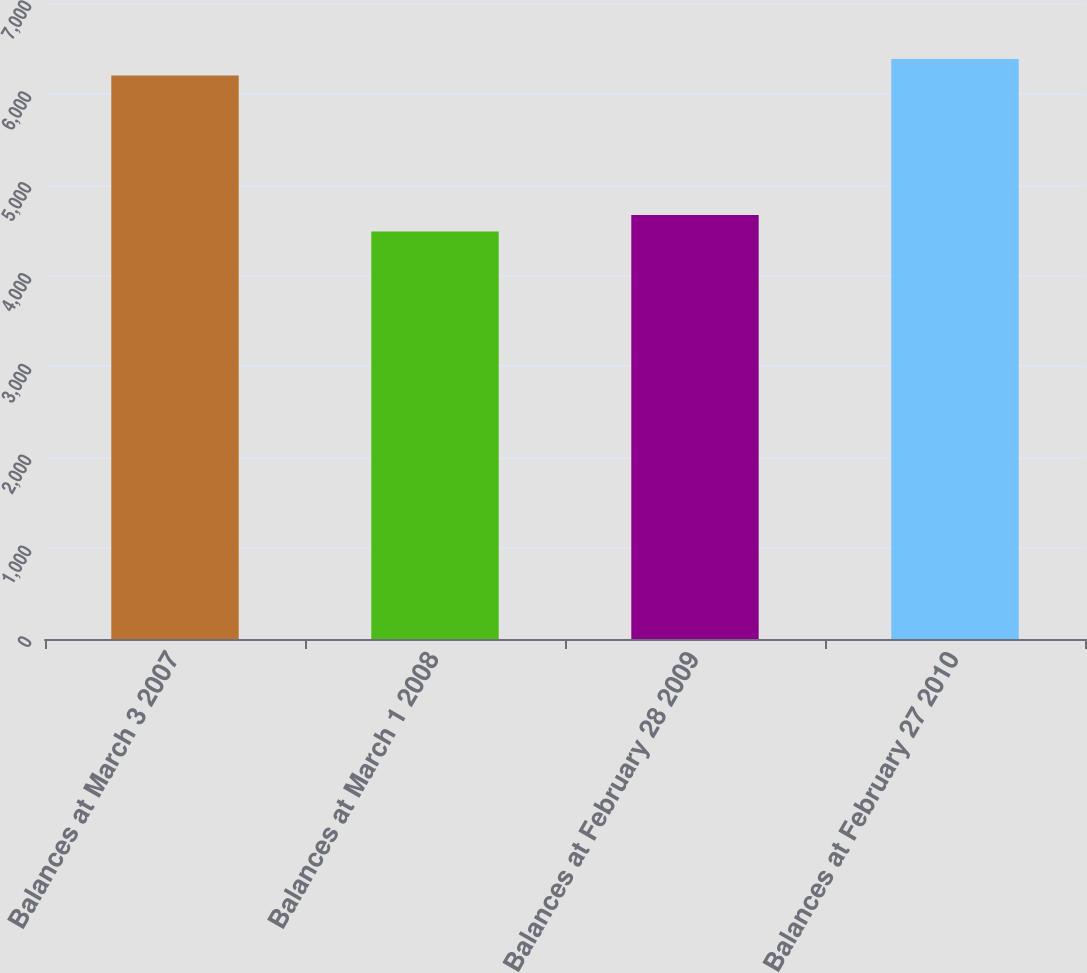<chart> <loc_0><loc_0><loc_500><loc_500><bar_chart><fcel>Balances at March 3 2007<fcel>Balances at March 1 2008<fcel>Balances at February 28 2009<fcel>Balances at February 27 2010<nl><fcel>6201<fcel>4484<fcel>4667.6<fcel>6384.6<nl></chart> 